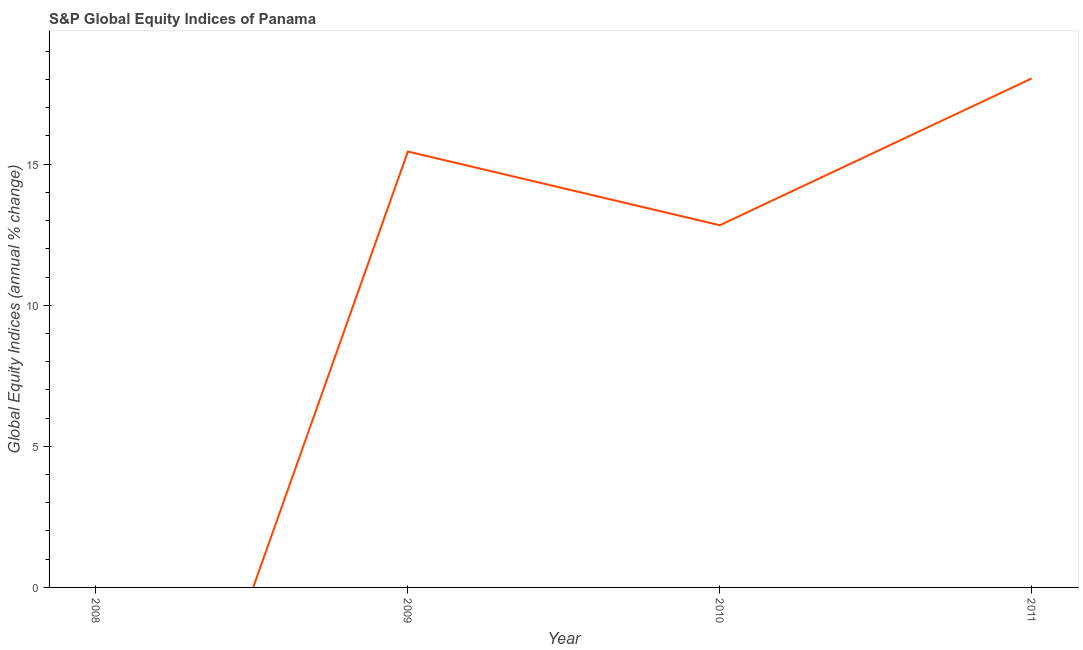What is the s&p global equity indices in 2008?
Ensure brevity in your answer.  0. Across all years, what is the maximum s&p global equity indices?
Your answer should be very brief. 18.04. Across all years, what is the minimum s&p global equity indices?
Provide a short and direct response. 0. In which year was the s&p global equity indices maximum?
Provide a succinct answer. 2011. What is the sum of the s&p global equity indices?
Keep it short and to the point. 46.32. What is the difference between the s&p global equity indices in 2009 and 2010?
Your answer should be compact. 2.61. What is the average s&p global equity indices per year?
Your answer should be compact. 11.58. What is the median s&p global equity indices?
Provide a succinct answer. 14.14. What is the ratio of the s&p global equity indices in 2009 to that in 2011?
Provide a short and direct response. 0.86. Is the s&p global equity indices in 2010 less than that in 2011?
Your response must be concise. Yes. What is the difference between the highest and the second highest s&p global equity indices?
Give a very brief answer. 2.59. What is the difference between the highest and the lowest s&p global equity indices?
Offer a terse response. 18.04. In how many years, is the s&p global equity indices greater than the average s&p global equity indices taken over all years?
Your answer should be compact. 3. How many lines are there?
Ensure brevity in your answer.  1. Does the graph contain grids?
Make the answer very short. No. What is the title of the graph?
Make the answer very short. S&P Global Equity Indices of Panama. What is the label or title of the X-axis?
Offer a very short reply. Year. What is the label or title of the Y-axis?
Provide a succinct answer. Global Equity Indices (annual % change). What is the Global Equity Indices (annual % change) in 2009?
Make the answer very short. 15.45. What is the Global Equity Indices (annual % change) in 2010?
Ensure brevity in your answer.  12.83. What is the Global Equity Indices (annual % change) of 2011?
Provide a succinct answer. 18.04. What is the difference between the Global Equity Indices (annual % change) in 2009 and 2010?
Offer a terse response. 2.61. What is the difference between the Global Equity Indices (annual % change) in 2009 and 2011?
Offer a terse response. -2.59. What is the difference between the Global Equity Indices (annual % change) in 2010 and 2011?
Your answer should be very brief. -5.2. What is the ratio of the Global Equity Indices (annual % change) in 2009 to that in 2010?
Your answer should be very brief. 1.2. What is the ratio of the Global Equity Indices (annual % change) in 2009 to that in 2011?
Keep it short and to the point. 0.86. What is the ratio of the Global Equity Indices (annual % change) in 2010 to that in 2011?
Your answer should be very brief. 0.71. 